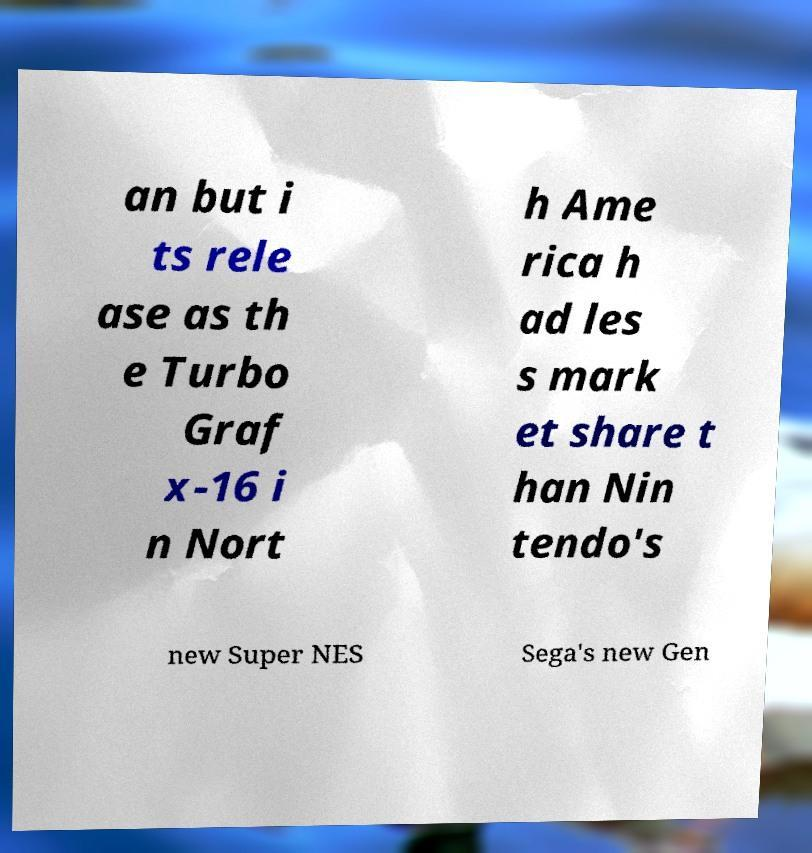Can you accurately transcribe the text from the provided image for me? an but i ts rele ase as th e Turbo Graf x-16 i n Nort h Ame rica h ad les s mark et share t han Nin tendo's new Super NES Sega's new Gen 